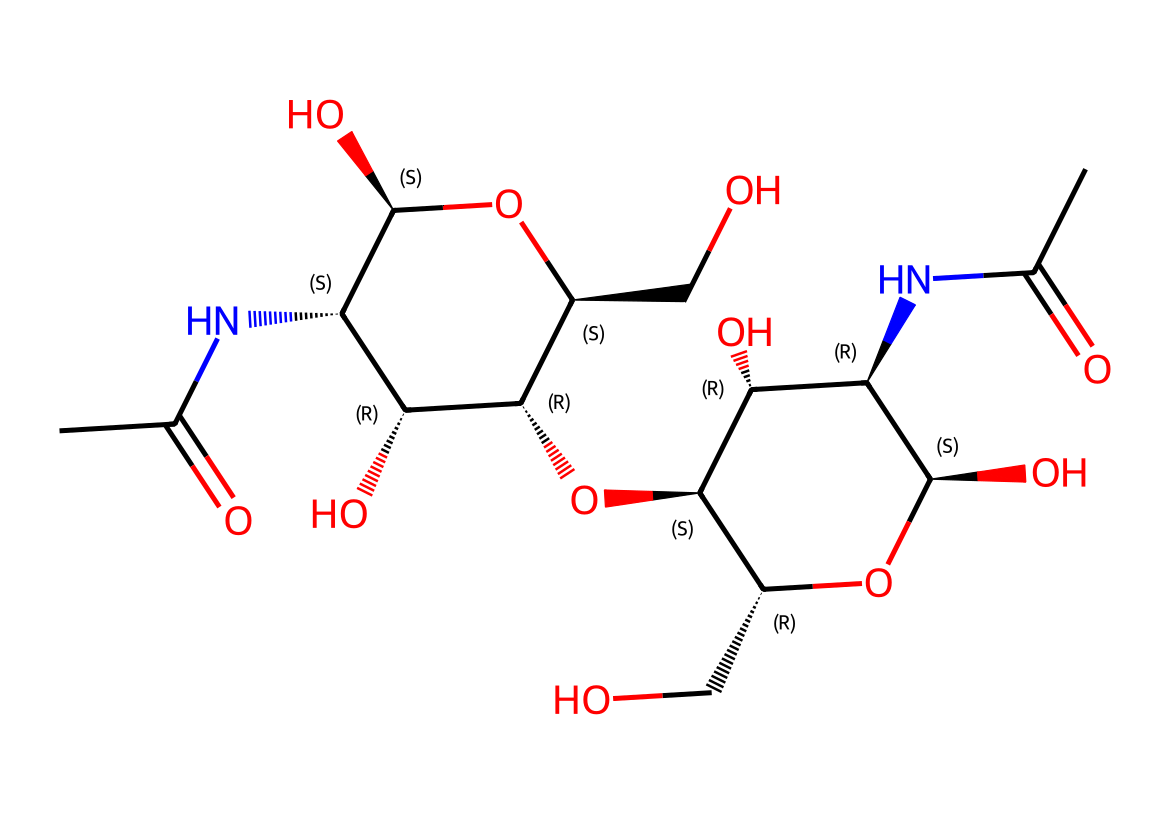What is the main functional group present in chitosan? The SMILES representation indicates that there are amide functional groups (NC(C)=O), as seen where nitrogen is directly connected to a carbonyl group (CO). This highlights the presence of chitosan's amine functionalities.
Answer: amide How many hydroxyl groups are present in this chitosan structure? By analyzing the SMILES, we can identify multiple occurrences of -OH groups. Each instance of 'O' followed by a hydrogen indicates a hydroxyl group, which totals to three in this specific structure.
Answer: three What type of polymer is chitosan classified as? Chitosan is derived from chitin, which is a polysaccharide. The repeating units and structure show it is a biopolymer, characterized by multiple sugar units with amine functionalities.
Answer: biopolymer What is the degree of acetylation indicated in the structure based on the SMILES? The presence of segments NC(C)=O suggests that there are acetyl groups attached, indicating partial acetylation. Counting the instances of acetate groups leads to a determination of the degree of acetylation as a crucial factor in its solubility.
Answer: partially acetylated How does the presence of amino groups affect the solubility of chitosan in physiological conditions? Amino groups enhance solubility in acidic environments due to protonation, making chitosan more soluble in such conditions. The numerous amino functionalities present indicate a significant impact on its solubility profile in biological applications.
Answer: increases solubility 